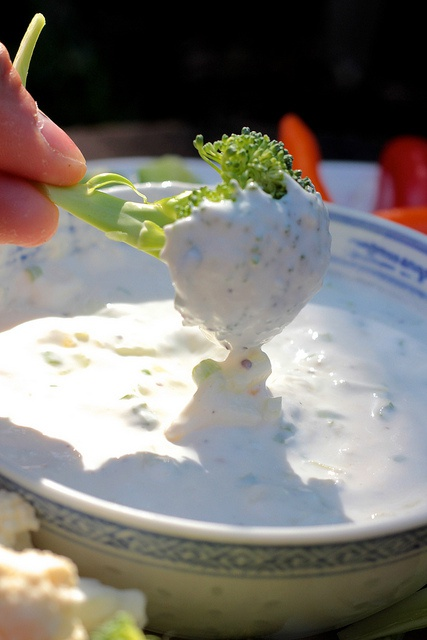Describe the objects in this image and their specific colors. I can see bowl in black, darkgray, white, gray, and darkgreen tones, broccoli in black, darkgray, gray, and olive tones, and people in black, brown, and maroon tones in this image. 